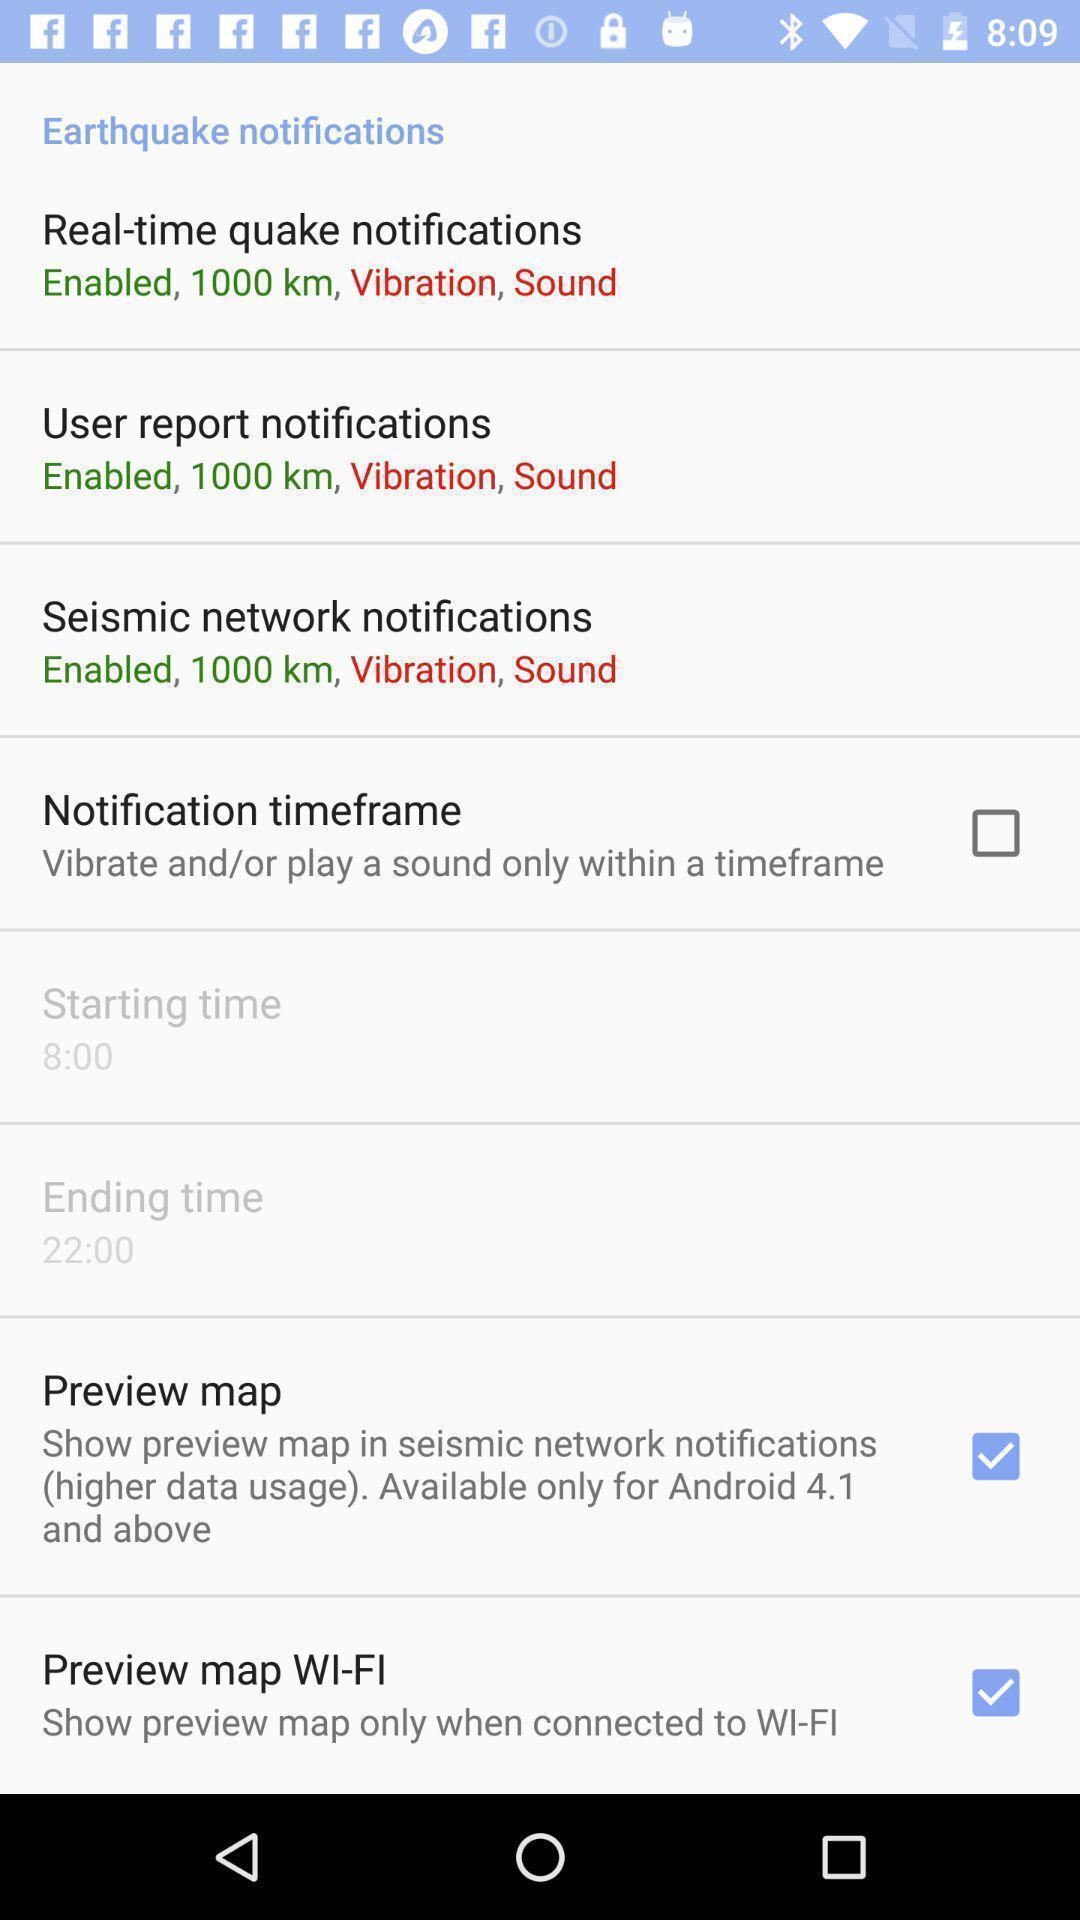Describe this image in words. Screen displaying multiple notification options. 